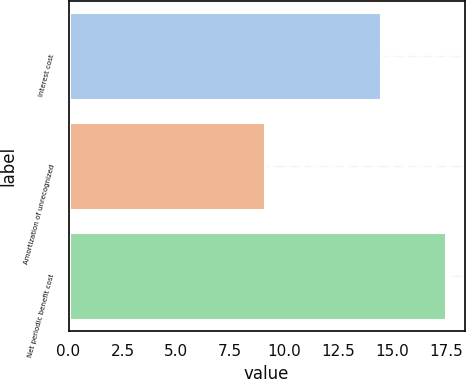Convert chart. <chart><loc_0><loc_0><loc_500><loc_500><bar_chart><fcel>Interest cost<fcel>Amortization of unrecognized<fcel>Net periodic benefit cost<nl><fcel>14.5<fcel>9.1<fcel>17.5<nl></chart> 